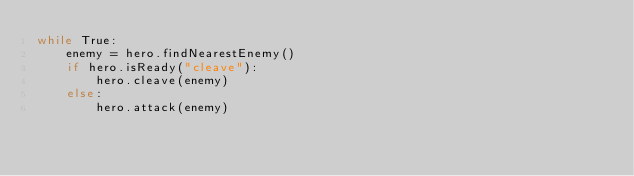Convert code to text. <code><loc_0><loc_0><loc_500><loc_500><_Python_>while True:
    enemy = hero.findNearestEnemy()
    if hero.isReady("cleave"):
        hero.cleave(enemy)
    else:
        hero.attack(enemy)
</code> 